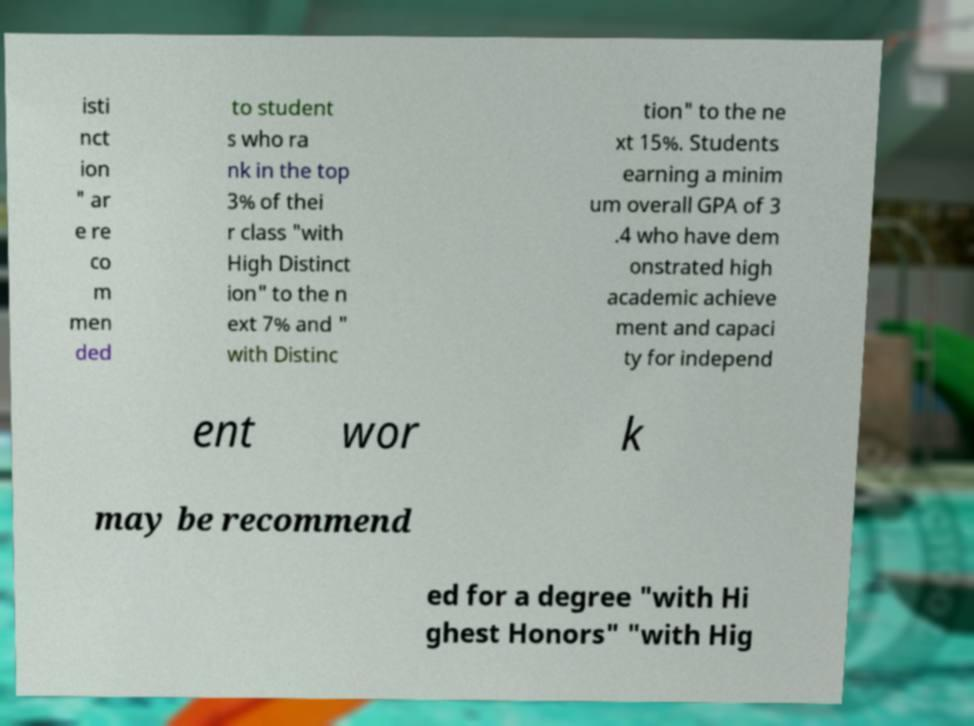Could you assist in decoding the text presented in this image and type it out clearly? isti nct ion " ar e re co m men ded to student s who ra nk in the top 3% of thei r class "with High Distinct ion" to the n ext 7% and " with Distinc tion" to the ne xt 15%. Students earning a minim um overall GPA of 3 .4 who have dem onstrated high academic achieve ment and capaci ty for independ ent wor k may be recommend ed for a degree "with Hi ghest Honors" "with Hig 